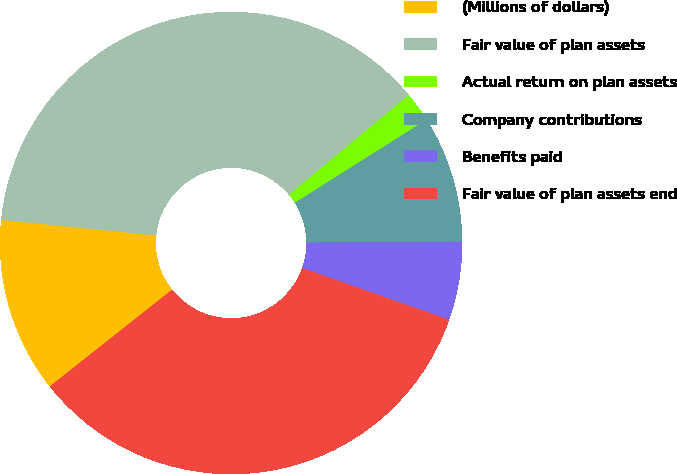<chart> <loc_0><loc_0><loc_500><loc_500><pie_chart><fcel>(Millions of dollars)<fcel>Fair value of plan assets<fcel>Actual return on plan assets<fcel>Company contributions<fcel>Benefits paid<fcel>Fair value of plan assets end<nl><fcel>12.24%<fcel>37.35%<fcel>2.1%<fcel>8.86%<fcel>5.48%<fcel>33.97%<nl></chart> 